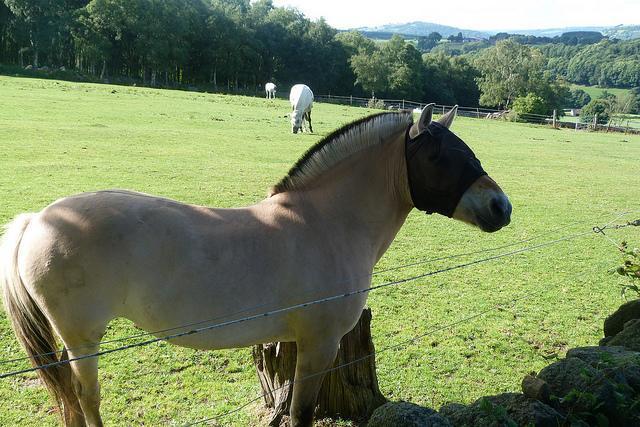How many horses?
Give a very brief answer. 3. How many eyes are shown?
Give a very brief answer. 1. How many black umbrellas are in the image?
Give a very brief answer. 0. 